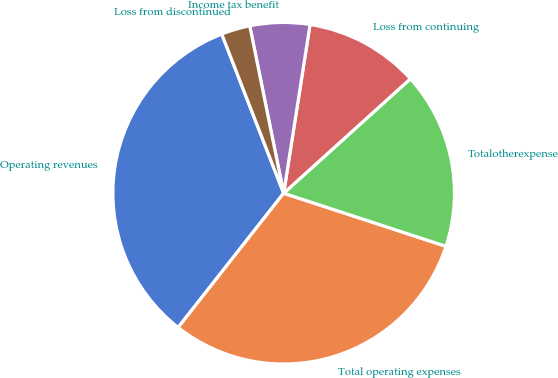Convert chart to OTSL. <chart><loc_0><loc_0><loc_500><loc_500><pie_chart><fcel>Operating revenues<fcel>Total operating expenses<fcel>Totalotherexpense<fcel>Loss from continuing<fcel>Income tax benefit<fcel>Loss from discontinued<nl><fcel>33.49%<fcel>30.57%<fcel>16.72%<fcel>10.84%<fcel>5.65%<fcel>2.72%<nl></chart> 